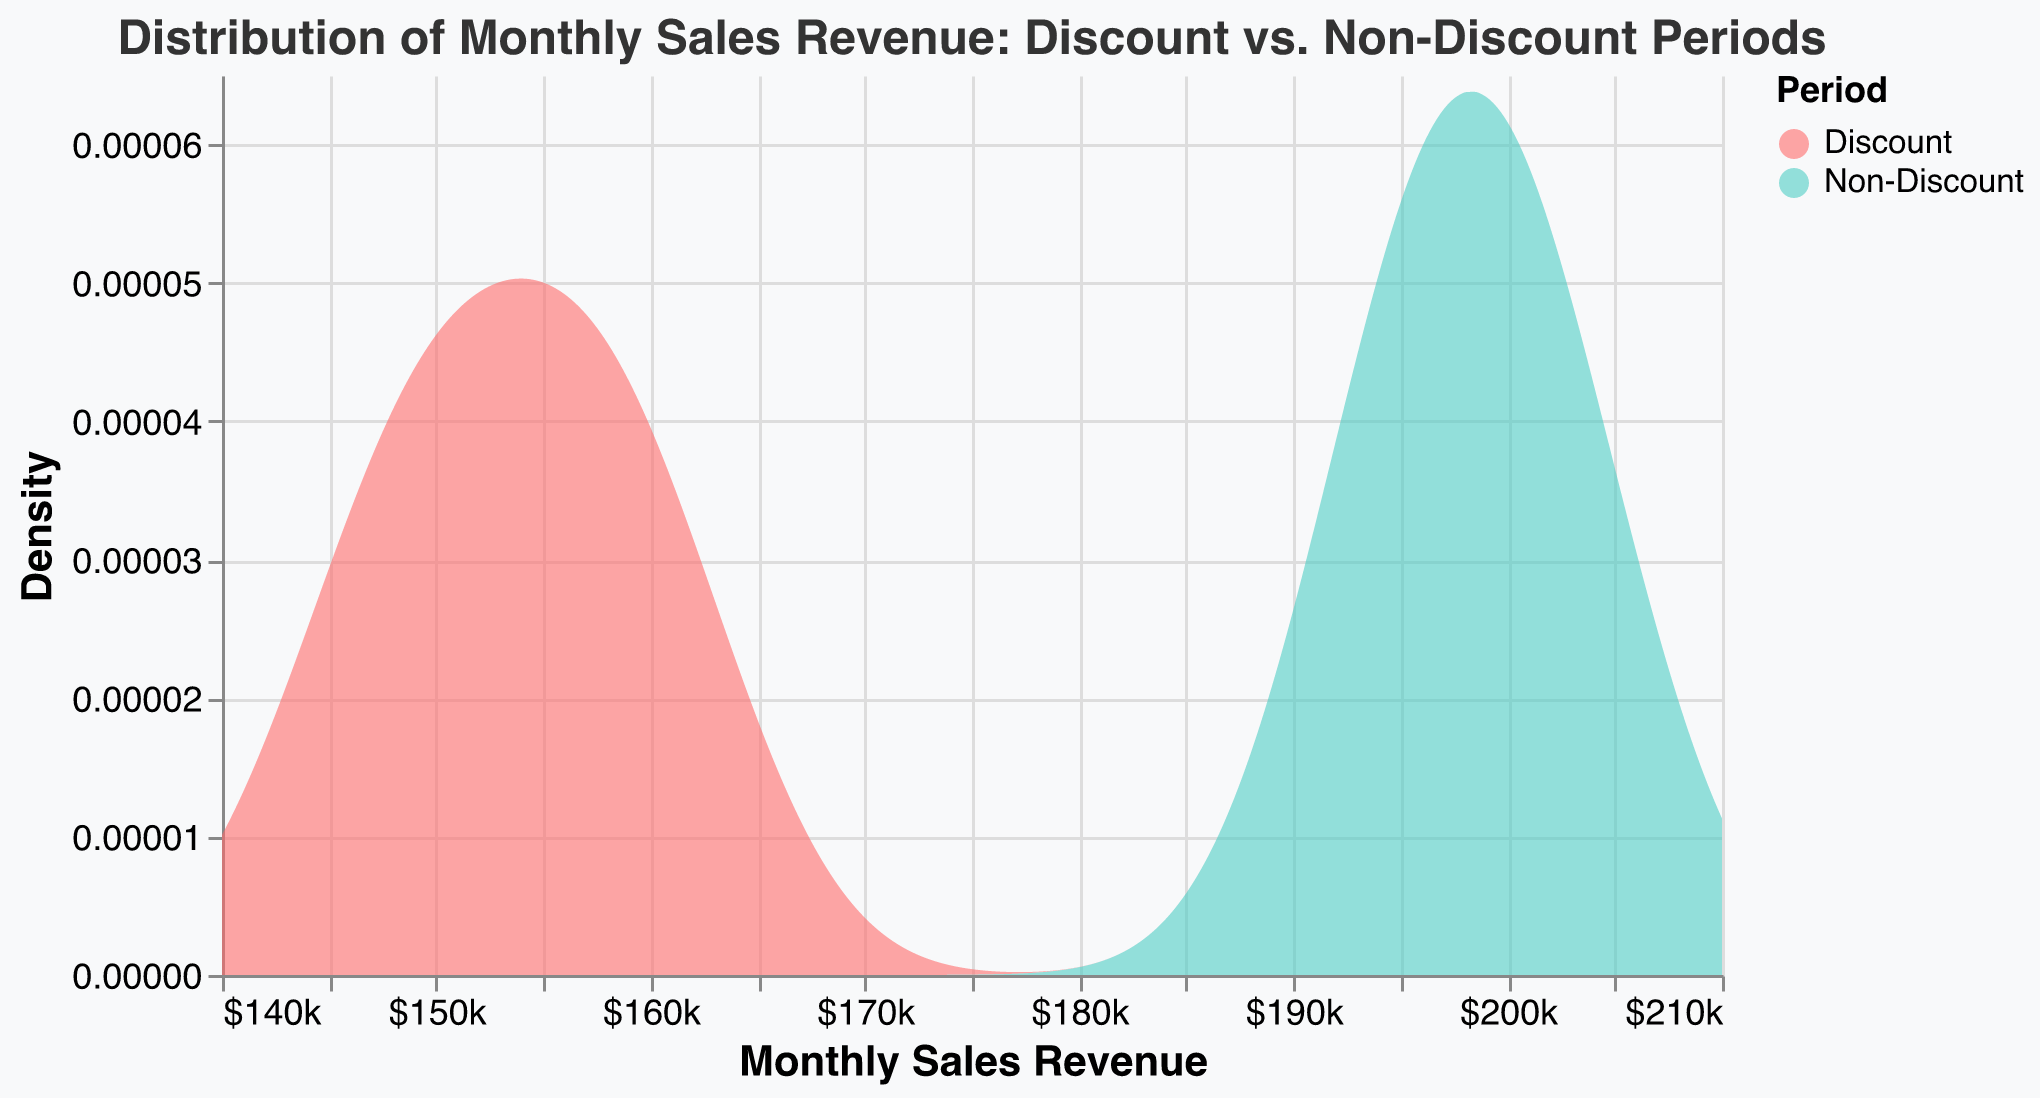What is the title of the figure? The title is located at the top of the figure, and it reads: "Distribution of Monthly Sales Revenue: Discount vs. Non-Discount Periods."
Answer: Distribution of Monthly Sales Revenue: Discount vs. Non-Discount Periods What does the x-axis represent? The x-axis represents the "Monthly Sales Revenue," as indicated by the axis title at the bottom.
Answer: Monthly Sales Revenue How many color categories are shown in the legend? The legend displays two categories, one for each period.
Answer: Two Which period generally has higher monthly sales revenue, Discount or Non-Discount? By examining the x-axis range covered by each distribution, the Non-Discount period consistently shows higher monthly sales revenue values.
Answer: Non-Discount What is the highest monthly sales revenue observed during the Discount period? The peak value for the Discount period is at the rightmost end of the red-colored (Discount) distribution.
Answer: 162,000 What is the range of monthly sales revenue values for the Non-Discount period? The range is identified by the spread of the green-colored (Non-Discount) distribution along the x-axis.
Answer: 193,000 to 205,000 Which period shows a higher density peak on the y-axis? The peak height on the y-axis for each color indicates density, and the green-colored (Non-Discount) distribution shows a higher peak.
Answer: Non-Discount What is the central tendency (around where most data points cluster) for the Discount period? By observing where the red-colored (Discount) distribution is tallest and appears most concentrated, the central tendency is around 155,000.
Answer: Around 155,000 What is the approximate bandwidth used for the density distribution? The smoothness of the plot indicates the bandwidth, and it is approximately specified to be 5,000.
Answer: 5,000 